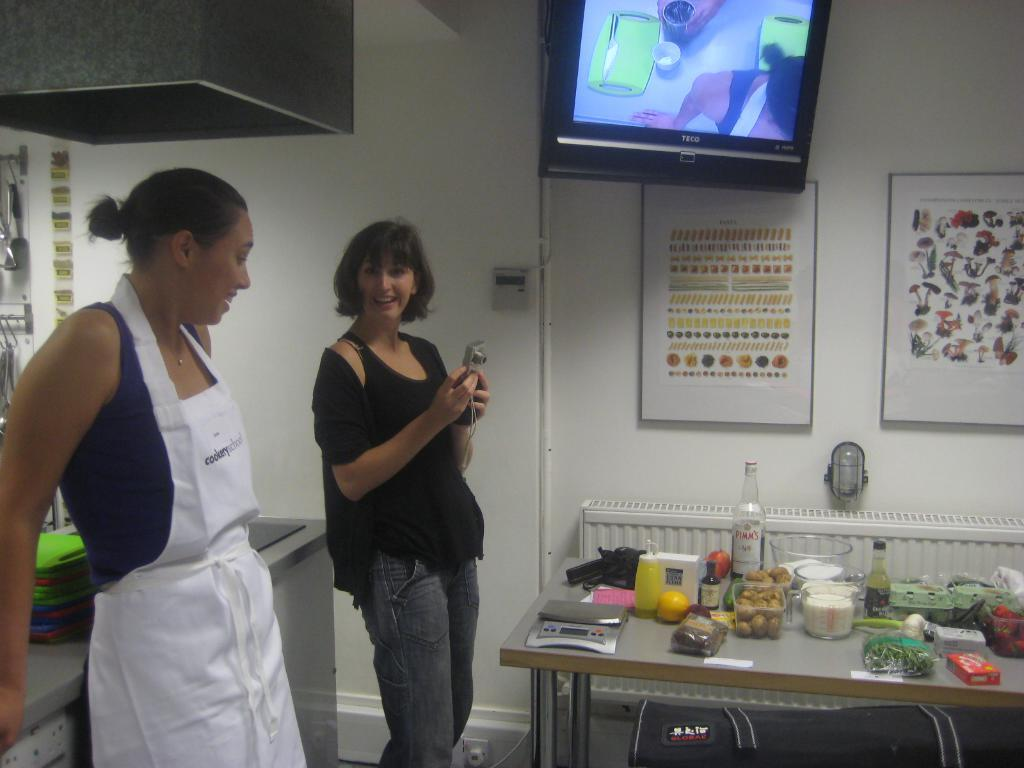<image>
Offer a succinct explanation of the picture presented. A television mounted on the wall is by brand TECO. 